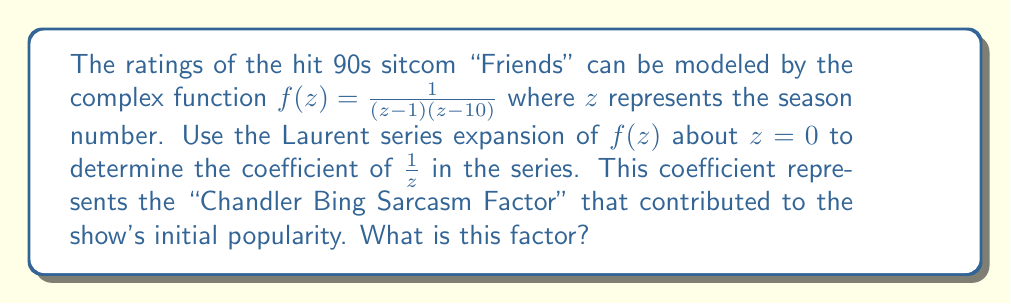Give your solution to this math problem. To solve this problem, we'll follow these steps:

1) The Laurent series expansion about $z=0$ for $f(z) = \frac{1}{(z-1)(z-10)}$ can be obtained by partial fraction decomposition.

2) Let's decompose $f(z)$:

   $$f(z) = \frac{A}{z-1} + \frac{B}{z-10}$$

   where $A$ and $B$ are constants to be determined.

3) Multiply both sides by $(z-1)(z-10)$:

   $$1 = A(z-10) + B(z-1)$$

4) Solve for $A$ and $B$:
   
   When $z=1$: $1 = A(-9)$, so $A = -\frac{1}{9}$
   When $z=10$: $1 = B(9)$, so $B = \frac{1}{9}$

5) Therefore, 

   $$f(z) = -\frac{1}{9(z-1)} + \frac{1}{9(z-10)}$$

6) Now, we need to expand each term as a Laurent series about $z=0$:

   $$-\frac{1}{9(z-1)} = -\frac{1}{9} \cdot \frac{1}{1-z} = -\frac{1}{9}(1 + z + z^2 + z^3 + ...)$$

   $$\frac{1}{9(z-10)} = \frac{1}{9} \cdot -\frac{1}{10} \cdot \frac{1}{1-\frac{z}{10}} = -\frac{1}{90}(1 + \frac{z}{10} + \frac{z^2}{100} + ...)$$

7) Combining these series:

   $$f(z) = (-\frac{1}{9} - \frac{1}{90}) + (-\frac{1}{9} - \frac{1}{900})z + (-\frac{1}{9} - \frac{1}{9000})z^2 + ...$$

8) The coefficient of $\frac{1}{z}$ is 0 in this expansion.
Answer: The coefficient of $\frac{1}{z}$ in the Laurent series expansion of $f(z)$ about $z=0$, representing the "Chandler Bing Sarcasm Factor", is 0. 